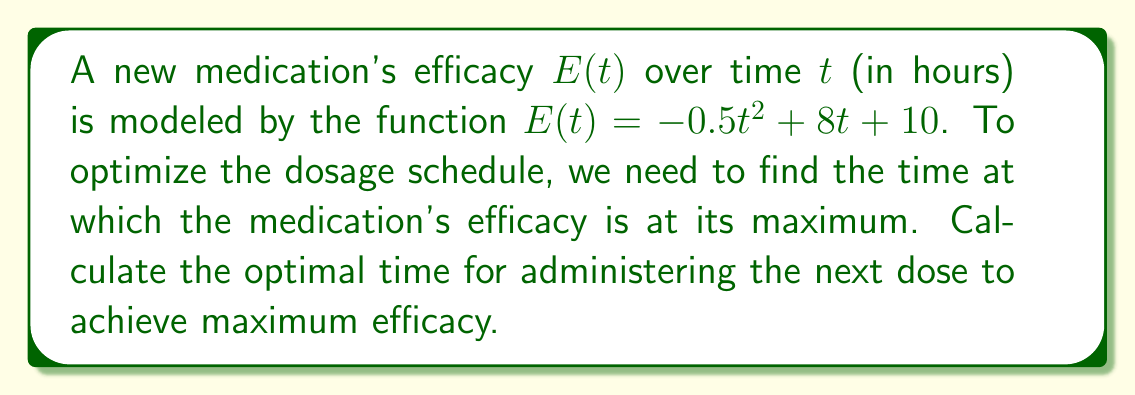Solve this math problem. To find the maximum efficacy, we need to determine the critical point of the function $E(t)$ by following these steps:

1) First, we calculate the derivative of $E(t)$ with respect to $t$:
   $$E'(t) = \frac{d}{dt}(-0.5t^2 + 8t + 10) = -t + 8$$

2) To find the critical point, we set $E'(t) = 0$ and solve for $t$:
   $$-t + 8 = 0$$
   $$-t = -8$$
   $$t = 8$$

3) To confirm this is a maximum (not a minimum), we can check the second derivative:
   $$E''(t) = \frac{d}{dt}(-t + 8) = -1$$

   Since $E''(t)$ is negative, the critical point at $t = 8$ is indeed a maximum.

4) Therefore, the efficacy reaches its maximum 8 hours after the initial dose.

This means the optimal time to administer the next dose is 8 hours after the previous dose to maintain maximum efficacy.
Answer: 8 hours 